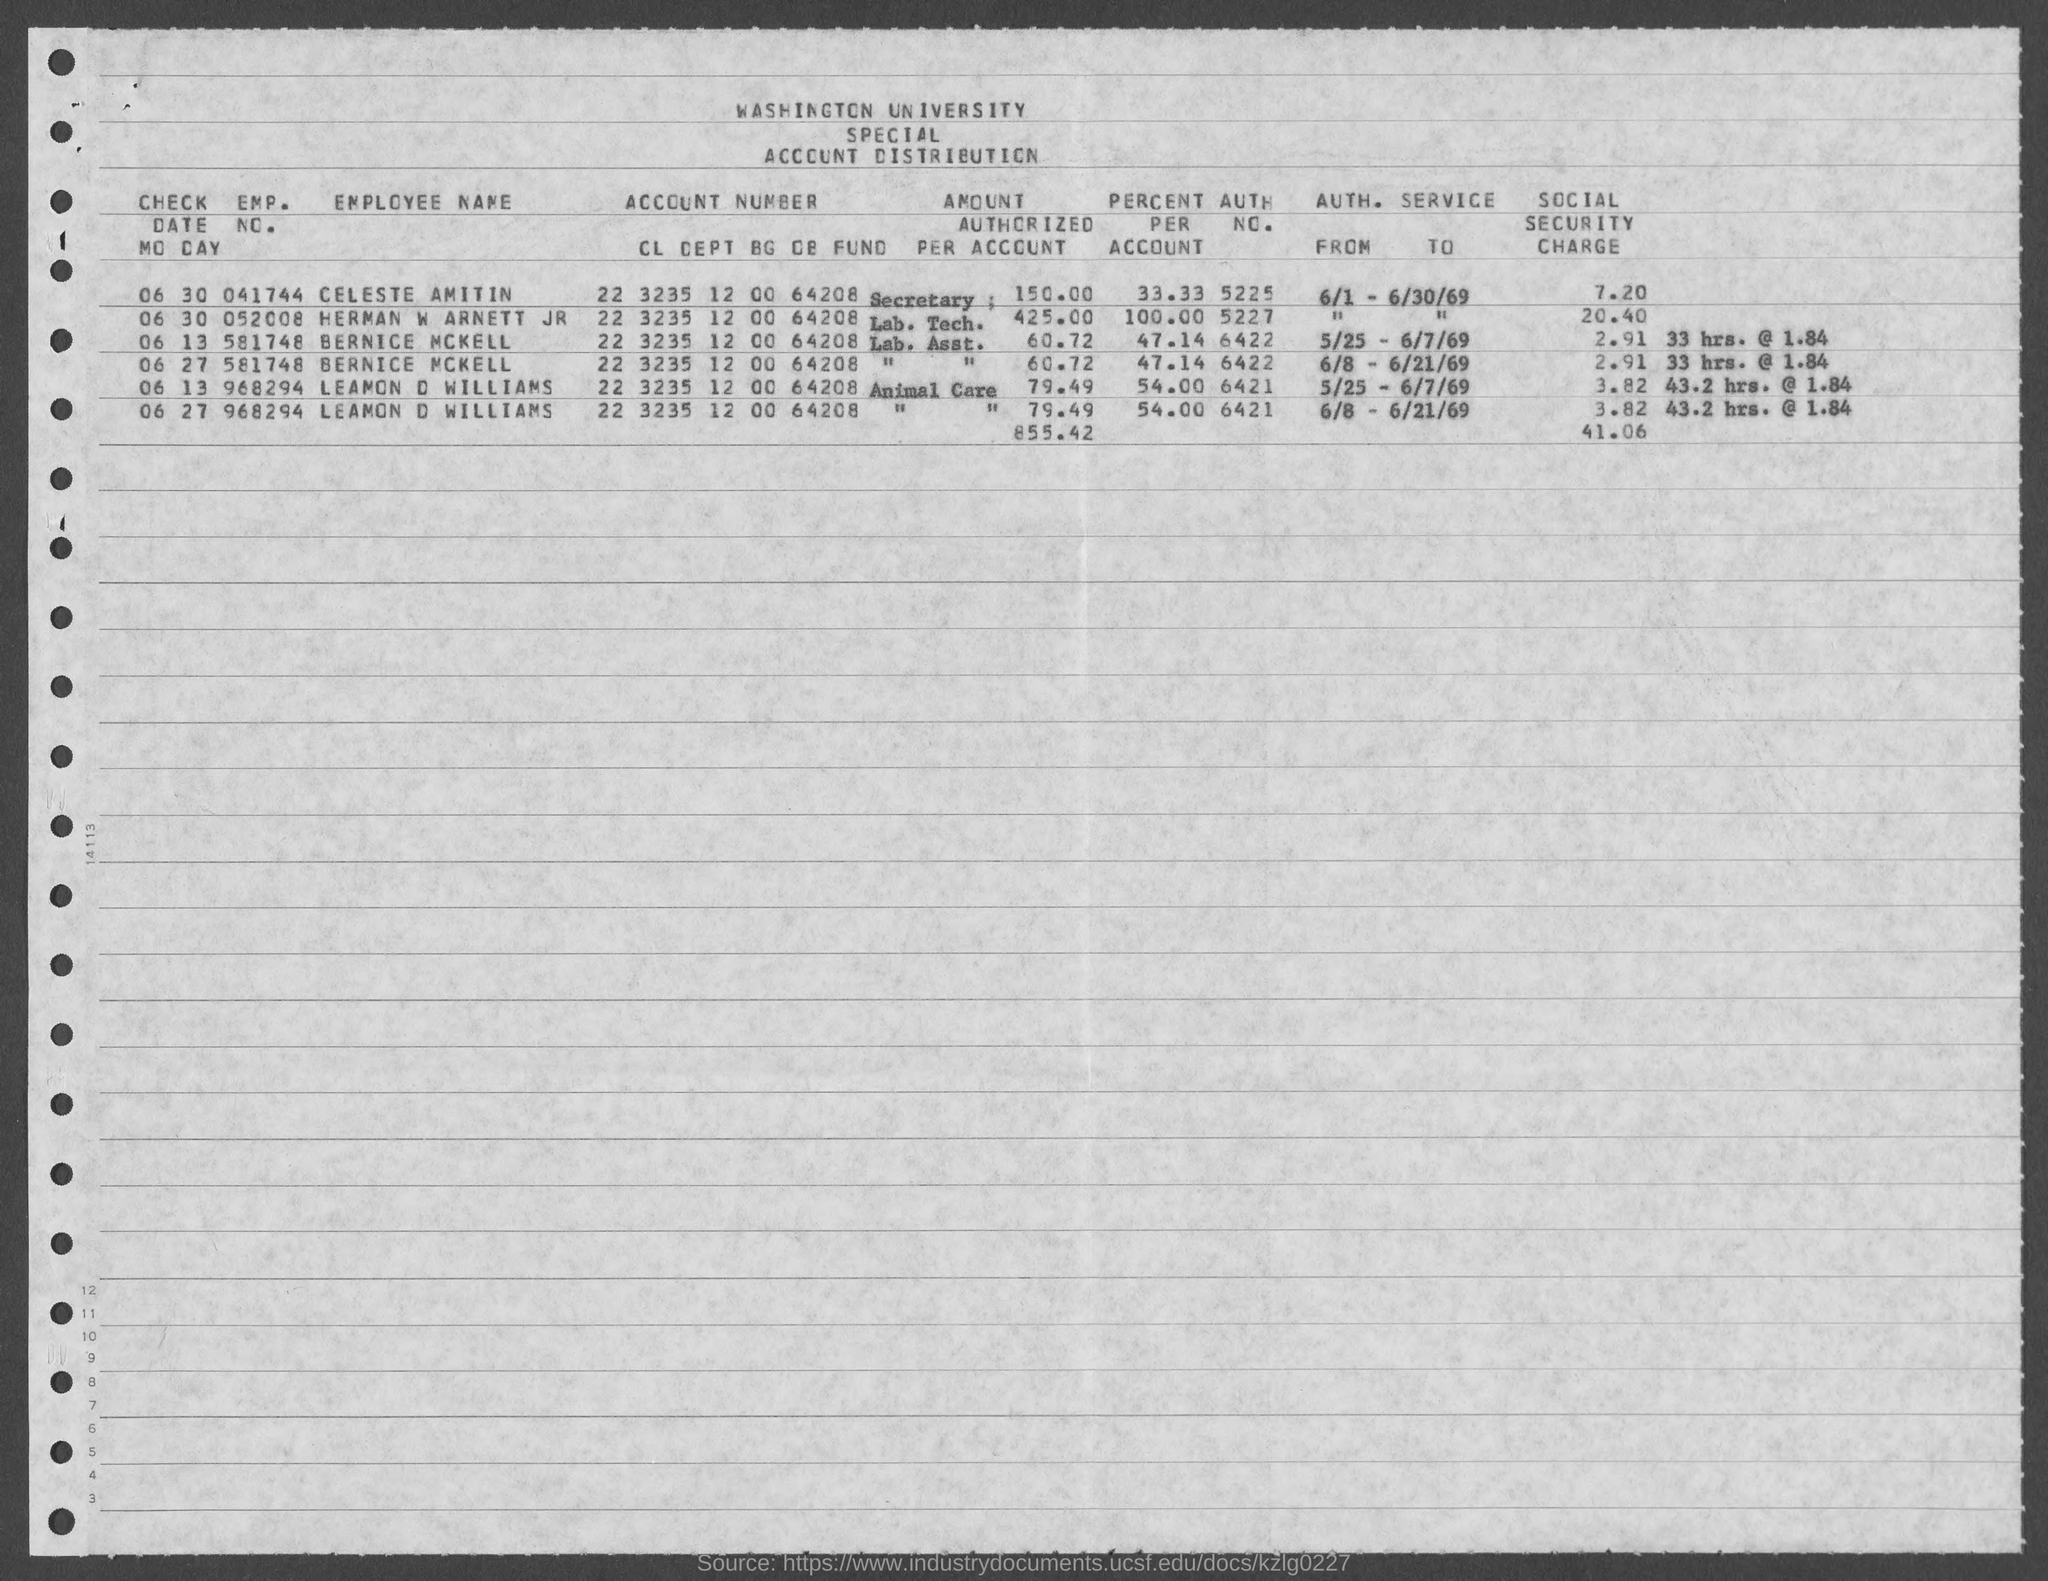Highlight a few significant elements in this photo. The authentication number for Lemon D. Williams is 6421. The employee number of Bernice McKell, as mentioned in the provided form, is 581748... The emp. no. of Celeste Amitin is 041744... Celeste Amitin's percent per account is 33.33... as indicated in the provided form. The value of the percentage for Bernice McKell as mentioned in the given form is 47.14%. 